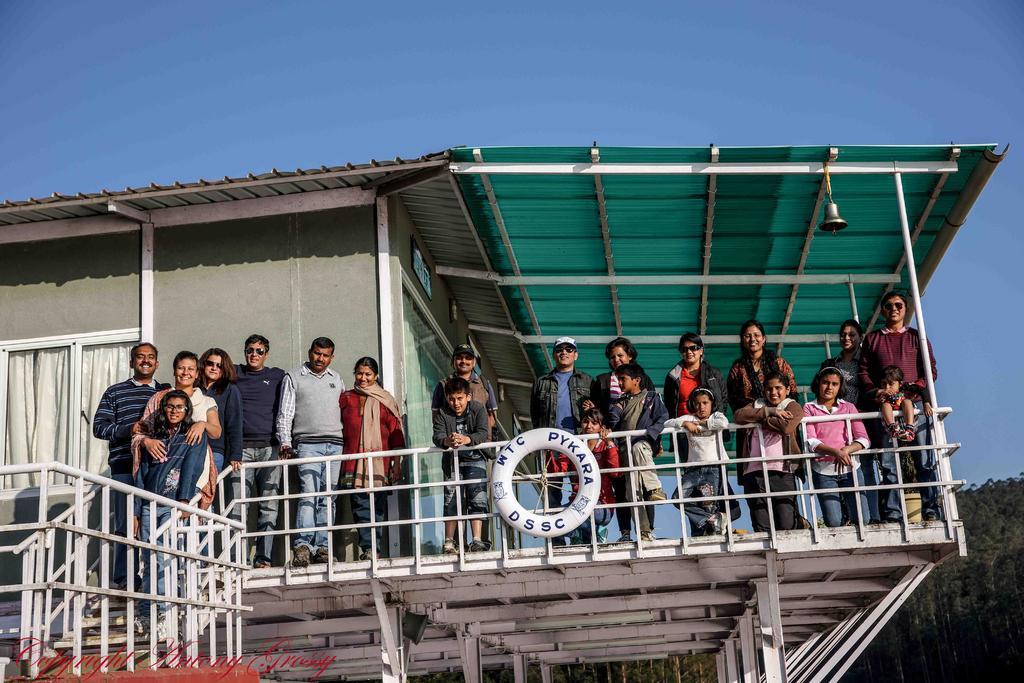Please provide a concise description of this image. In the picture we can see a house with a top floor with a railing and behind it, we can see some people with their children and behind them, we can see a wall with glass window and curtain inside it and beside it, we can see a green color shed to the house with poles to it and a bell hanged for it and under the house we can see some poles and inside the house we can see trees and behind we can see a sky. 